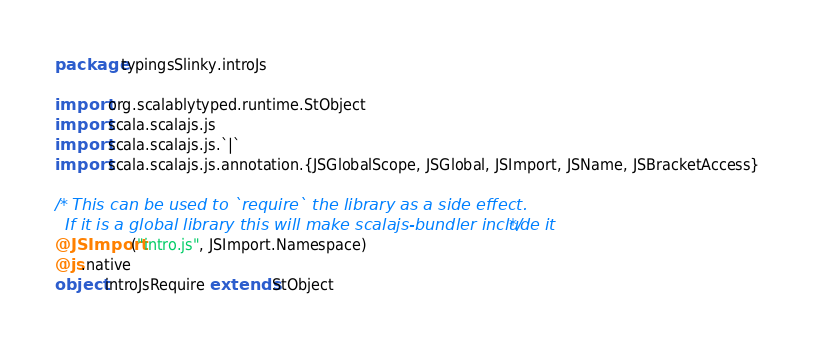<code> <loc_0><loc_0><loc_500><loc_500><_Scala_>package typingsSlinky.introJs

import org.scalablytyped.runtime.StObject
import scala.scalajs.js
import scala.scalajs.js.`|`
import scala.scalajs.js.annotation.{JSGlobalScope, JSGlobal, JSImport, JSName, JSBracketAccess}

/* This can be used to `require` the library as a side effect.
  If it is a global library this will make scalajs-bundler include it */
@JSImport("intro.js", JSImport.Namespace)
@js.native
object introJsRequire extends StObject
</code> 